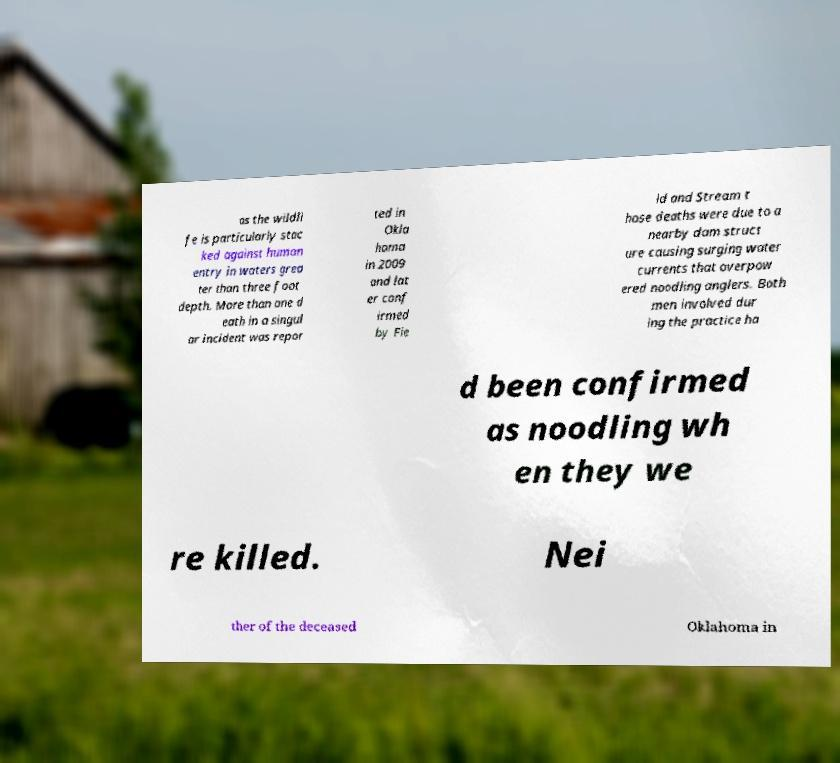For documentation purposes, I need the text within this image transcribed. Could you provide that? as the wildli fe is particularly stac ked against human entry in waters grea ter than three foot depth. More than one d eath in a singul ar incident was repor ted in Okla homa in 2009 and lat er conf irmed by Fie ld and Stream t hose deaths were due to a nearby dam struct ure causing surging water currents that overpow ered noodling anglers. Both men involved dur ing the practice ha d been confirmed as noodling wh en they we re killed. Nei ther of the deceased Oklahoma in 